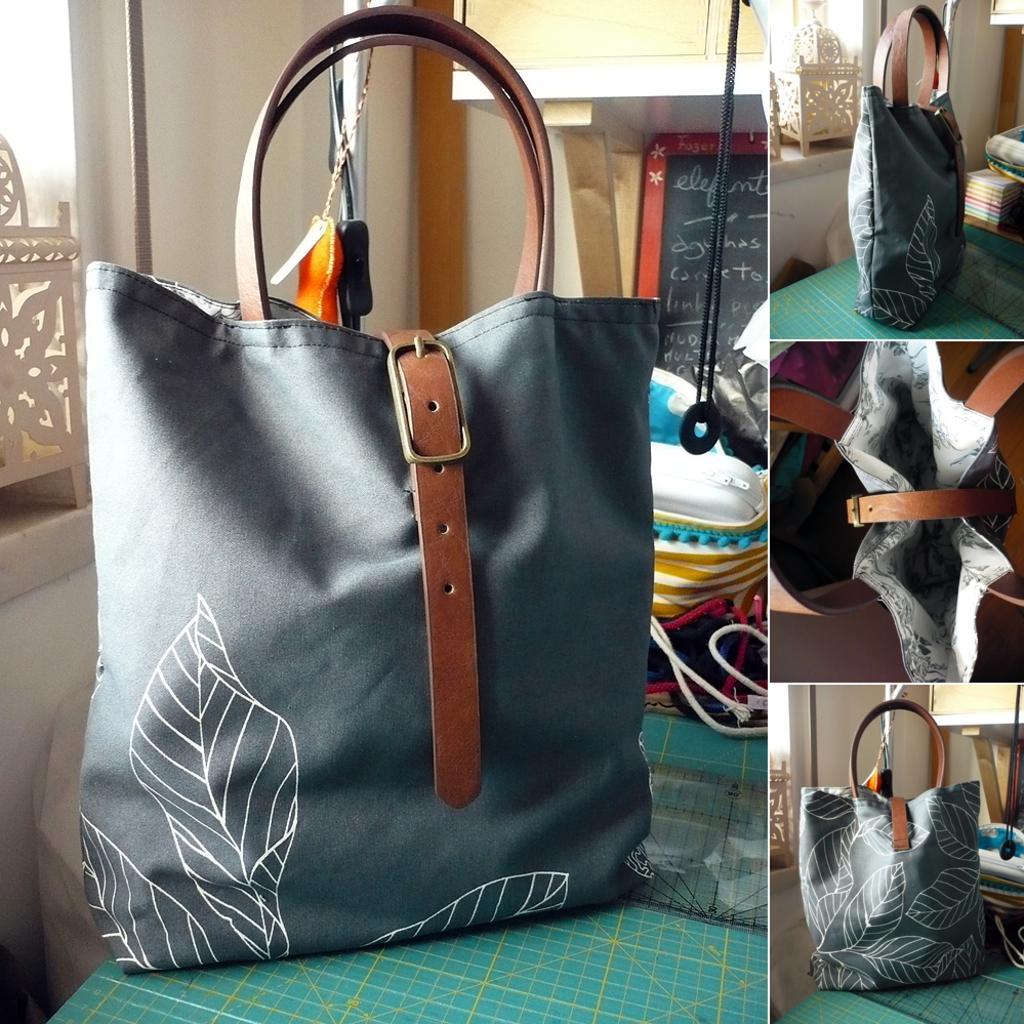Could you give a brief overview of what you see in this image? In this image, we can see a collage photo. The center of the image, we can see a ash color bag. Here it is belt. It is leather belt. This bag is placed on a table. Here we can see a measuring scale. Behind this bag, we can see few bags are placed. And this is a ring that is hung by the thread. And background, we can see some board. Something is text on it. Here we can see a white color wall. And here we can see a chain that is hang. In the right side of the image,few bags are placed on the table. Here we can see the inside of the bag. 